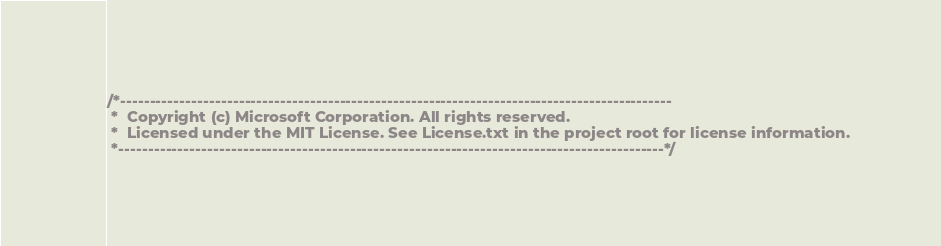Convert code to text. <code><loc_0><loc_0><loc_500><loc_500><_TypeScript_>/*---------------------------------------------------------------------------------------------
 *  Copyright (c) Microsoft Corporation. All rights reserved.
 *  Licensed under the MIT License. See License.txt in the project root for license information.
 *--------------------------------------------------------------------------------------------*/
</code> 